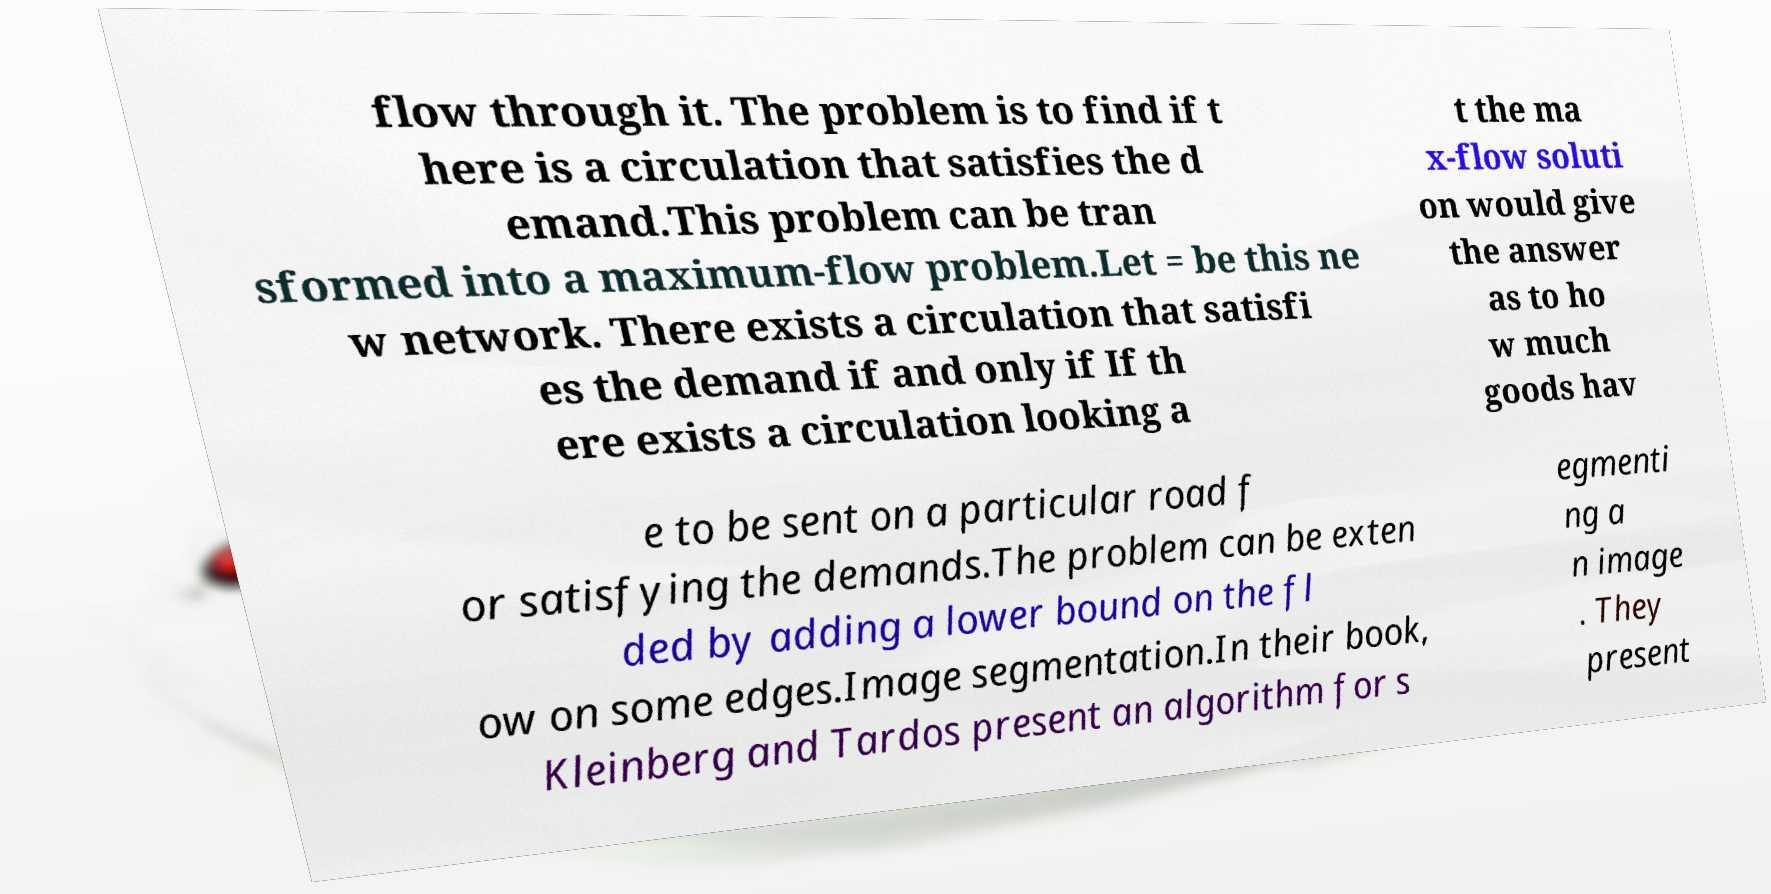Could you assist in decoding the text presented in this image and type it out clearly? flow through it. The problem is to find if t here is a circulation that satisfies the d emand.This problem can be tran sformed into a maximum-flow problem.Let = be this ne w network. There exists a circulation that satisfi es the demand if and only if If th ere exists a circulation looking a t the ma x-flow soluti on would give the answer as to ho w much goods hav e to be sent on a particular road f or satisfying the demands.The problem can be exten ded by adding a lower bound on the fl ow on some edges.Image segmentation.In their book, Kleinberg and Tardos present an algorithm for s egmenti ng a n image . They present 